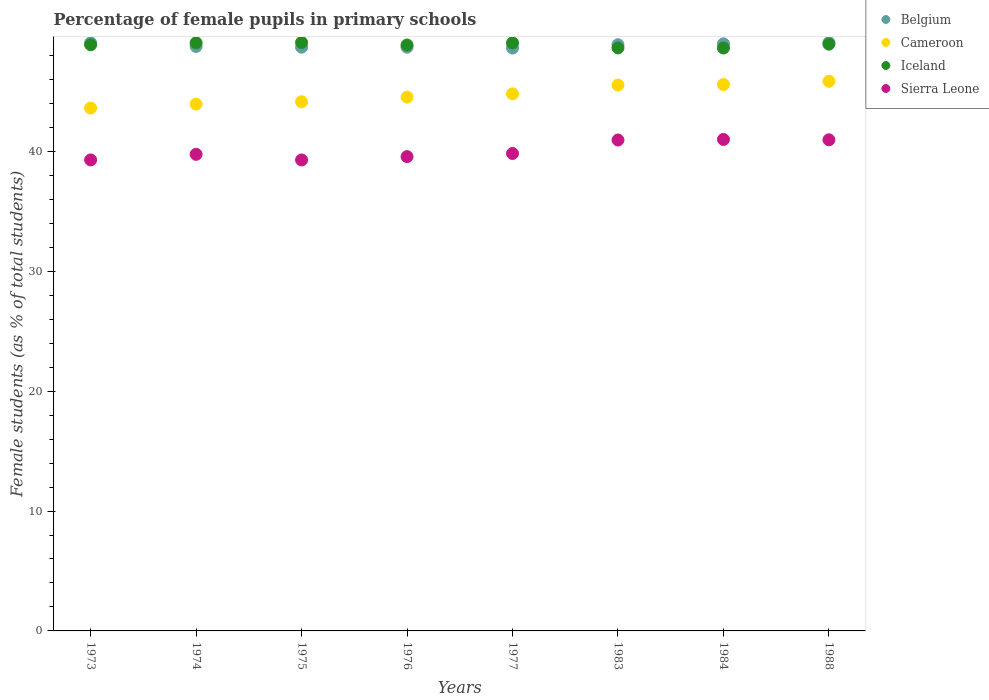Is the number of dotlines equal to the number of legend labels?
Keep it short and to the point. Yes. What is the percentage of female pupils in primary schools in Iceland in 1976?
Offer a terse response. 48.88. Across all years, what is the maximum percentage of female pupils in primary schools in Iceland?
Give a very brief answer. 49.09. Across all years, what is the minimum percentage of female pupils in primary schools in Sierra Leone?
Your response must be concise. 39.29. In which year was the percentage of female pupils in primary schools in Cameroon maximum?
Make the answer very short. 1988. What is the total percentage of female pupils in primary schools in Sierra Leone in the graph?
Offer a very short reply. 320.65. What is the difference between the percentage of female pupils in primary schools in Belgium in 1977 and that in 1988?
Provide a succinct answer. -0.45. What is the difference between the percentage of female pupils in primary schools in Cameroon in 1984 and the percentage of female pupils in primary schools in Iceland in 1976?
Your answer should be very brief. -3.3. What is the average percentage of female pupils in primary schools in Sierra Leone per year?
Your answer should be very brief. 40.08. In the year 1975, what is the difference between the percentage of female pupils in primary schools in Cameroon and percentage of female pupils in primary schools in Belgium?
Offer a terse response. -4.55. What is the ratio of the percentage of female pupils in primary schools in Belgium in 1973 to that in 1977?
Offer a terse response. 1.01. What is the difference between the highest and the second highest percentage of female pupils in primary schools in Sierra Leone?
Give a very brief answer. 0.03. What is the difference between the highest and the lowest percentage of female pupils in primary schools in Cameroon?
Ensure brevity in your answer.  2.23. In how many years, is the percentage of female pupils in primary schools in Cameroon greater than the average percentage of female pupils in primary schools in Cameroon taken over all years?
Your response must be concise. 4. Is the sum of the percentage of female pupils in primary schools in Sierra Leone in 1975 and 1984 greater than the maximum percentage of female pupils in primary schools in Cameroon across all years?
Make the answer very short. Yes. Does the percentage of female pupils in primary schools in Iceland monotonically increase over the years?
Your response must be concise. No. Is the percentage of female pupils in primary schools in Sierra Leone strictly greater than the percentage of female pupils in primary schools in Iceland over the years?
Ensure brevity in your answer.  No. How many dotlines are there?
Your answer should be compact. 4. How many years are there in the graph?
Keep it short and to the point. 8. Does the graph contain grids?
Offer a very short reply. No. How are the legend labels stacked?
Provide a succinct answer. Vertical. What is the title of the graph?
Provide a short and direct response. Percentage of female pupils in primary schools. What is the label or title of the Y-axis?
Your answer should be very brief. Female students (as % of total students). What is the Female students (as % of total students) in Belgium in 1973?
Keep it short and to the point. 49.05. What is the Female students (as % of total students) in Cameroon in 1973?
Ensure brevity in your answer.  43.62. What is the Female students (as % of total students) of Iceland in 1973?
Give a very brief answer. 48.9. What is the Female students (as % of total students) in Sierra Leone in 1973?
Make the answer very short. 39.29. What is the Female students (as % of total students) of Belgium in 1974?
Your answer should be very brief. 48.76. What is the Female students (as % of total students) of Cameroon in 1974?
Your response must be concise. 43.95. What is the Female students (as % of total students) in Iceland in 1974?
Keep it short and to the point. 49.06. What is the Female students (as % of total students) of Sierra Leone in 1974?
Ensure brevity in your answer.  39.76. What is the Female students (as % of total students) of Belgium in 1975?
Make the answer very short. 48.69. What is the Female students (as % of total students) of Cameroon in 1975?
Give a very brief answer. 44.14. What is the Female students (as % of total students) of Iceland in 1975?
Your answer should be compact. 49.09. What is the Female students (as % of total students) in Sierra Leone in 1975?
Give a very brief answer. 39.29. What is the Female students (as % of total students) of Belgium in 1976?
Provide a succinct answer. 48.69. What is the Female students (as % of total students) of Cameroon in 1976?
Keep it short and to the point. 44.53. What is the Female students (as % of total students) in Iceland in 1976?
Provide a short and direct response. 48.88. What is the Female students (as % of total students) of Sierra Leone in 1976?
Provide a succinct answer. 39.57. What is the Female students (as % of total students) of Belgium in 1977?
Provide a short and direct response. 48.62. What is the Female students (as % of total students) in Cameroon in 1977?
Provide a succinct answer. 44.81. What is the Female students (as % of total students) of Iceland in 1977?
Provide a succinct answer. 49.05. What is the Female students (as % of total students) in Sierra Leone in 1977?
Your answer should be compact. 39.83. What is the Female students (as % of total students) of Belgium in 1983?
Ensure brevity in your answer.  48.9. What is the Female students (as % of total students) of Cameroon in 1983?
Give a very brief answer. 45.54. What is the Female students (as % of total students) in Iceland in 1983?
Offer a terse response. 48.63. What is the Female students (as % of total students) of Sierra Leone in 1983?
Offer a very short reply. 40.95. What is the Female students (as % of total students) of Belgium in 1984?
Offer a terse response. 48.97. What is the Female students (as % of total students) of Cameroon in 1984?
Your response must be concise. 45.58. What is the Female students (as % of total students) of Iceland in 1984?
Provide a short and direct response. 48.63. What is the Female students (as % of total students) in Sierra Leone in 1984?
Your answer should be compact. 41. What is the Female students (as % of total students) of Belgium in 1988?
Provide a succinct answer. 49.07. What is the Female students (as % of total students) of Cameroon in 1988?
Make the answer very short. 45.85. What is the Female students (as % of total students) in Iceland in 1988?
Provide a short and direct response. 48.95. What is the Female students (as % of total students) of Sierra Leone in 1988?
Give a very brief answer. 40.97. Across all years, what is the maximum Female students (as % of total students) in Belgium?
Your answer should be very brief. 49.07. Across all years, what is the maximum Female students (as % of total students) of Cameroon?
Your response must be concise. 45.85. Across all years, what is the maximum Female students (as % of total students) in Iceland?
Your response must be concise. 49.09. Across all years, what is the maximum Female students (as % of total students) in Sierra Leone?
Ensure brevity in your answer.  41. Across all years, what is the minimum Female students (as % of total students) in Belgium?
Provide a succinct answer. 48.62. Across all years, what is the minimum Female students (as % of total students) of Cameroon?
Offer a terse response. 43.62. Across all years, what is the minimum Female students (as % of total students) of Iceland?
Give a very brief answer. 48.63. Across all years, what is the minimum Female students (as % of total students) of Sierra Leone?
Your response must be concise. 39.29. What is the total Female students (as % of total students) in Belgium in the graph?
Give a very brief answer. 390.77. What is the total Female students (as % of total students) of Cameroon in the graph?
Offer a very short reply. 358.01. What is the total Female students (as % of total students) in Iceland in the graph?
Offer a very short reply. 391.19. What is the total Female students (as % of total students) in Sierra Leone in the graph?
Ensure brevity in your answer.  320.65. What is the difference between the Female students (as % of total students) of Belgium in 1973 and that in 1974?
Your answer should be very brief. 0.29. What is the difference between the Female students (as % of total students) of Cameroon in 1973 and that in 1974?
Make the answer very short. -0.33. What is the difference between the Female students (as % of total students) in Iceland in 1973 and that in 1974?
Your answer should be compact. -0.16. What is the difference between the Female students (as % of total students) of Sierra Leone in 1973 and that in 1974?
Give a very brief answer. -0.46. What is the difference between the Female students (as % of total students) in Belgium in 1973 and that in 1975?
Provide a short and direct response. 0.36. What is the difference between the Female students (as % of total students) of Cameroon in 1973 and that in 1975?
Give a very brief answer. -0.52. What is the difference between the Female students (as % of total students) in Iceland in 1973 and that in 1975?
Your answer should be compact. -0.19. What is the difference between the Female students (as % of total students) of Sierra Leone in 1973 and that in 1975?
Offer a terse response. 0. What is the difference between the Female students (as % of total students) of Belgium in 1973 and that in 1976?
Your answer should be compact. 0.36. What is the difference between the Female students (as % of total students) of Cameroon in 1973 and that in 1976?
Your response must be concise. -0.91. What is the difference between the Female students (as % of total students) in Iceland in 1973 and that in 1976?
Offer a terse response. 0.02. What is the difference between the Female students (as % of total students) in Sierra Leone in 1973 and that in 1976?
Ensure brevity in your answer.  -0.27. What is the difference between the Female students (as % of total students) in Belgium in 1973 and that in 1977?
Your answer should be compact. 0.43. What is the difference between the Female students (as % of total students) in Cameroon in 1973 and that in 1977?
Offer a very short reply. -1.19. What is the difference between the Female students (as % of total students) in Iceland in 1973 and that in 1977?
Make the answer very short. -0.15. What is the difference between the Female students (as % of total students) in Sierra Leone in 1973 and that in 1977?
Ensure brevity in your answer.  -0.54. What is the difference between the Female students (as % of total students) in Belgium in 1973 and that in 1983?
Keep it short and to the point. 0.16. What is the difference between the Female students (as % of total students) in Cameroon in 1973 and that in 1983?
Your response must be concise. -1.92. What is the difference between the Female students (as % of total students) in Iceland in 1973 and that in 1983?
Offer a terse response. 0.27. What is the difference between the Female students (as % of total students) in Sierra Leone in 1973 and that in 1983?
Ensure brevity in your answer.  -1.66. What is the difference between the Female students (as % of total students) in Belgium in 1973 and that in 1984?
Provide a short and direct response. 0.08. What is the difference between the Female students (as % of total students) of Cameroon in 1973 and that in 1984?
Ensure brevity in your answer.  -1.96. What is the difference between the Female students (as % of total students) in Iceland in 1973 and that in 1984?
Keep it short and to the point. 0.27. What is the difference between the Female students (as % of total students) in Sierra Leone in 1973 and that in 1984?
Offer a terse response. -1.71. What is the difference between the Female students (as % of total students) in Belgium in 1973 and that in 1988?
Give a very brief answer. -0.02. What is the difference between the Female students (as % of total students) of Cameroon in 1973 and that in 1988?
Provide a succinct answer. -2.23. What is the difference between the Female students (as % of total students) in Iceland in 1973 and that in 1988?
Your response must be concise. -0.05. What is the difference between the Female students (as % of total students) in Sierra Leone in 1973 and that in 1988?
Give a very brief answer. -1.68. What is the difference between the Female students (as % of total students) in Belgium in 1974 and that in 1975?
Your answer should be compact. 0.07. What is the difference between the Female students (as % of total students) in Cameroon in 1974 and that in 1975?
Offer a very short reply. -0.19. What is the difference between the Female students (as % of total students) in Iceland in 1974 and that in 1975?
Give a very brief answer. -0.03. What is the difference between the Female students (as % of total students) of Sierra Leone in 1974 and that in 1975?
Give a very brief answer. 0.47. What is the difference between the Female students (as % of total students) in Belgium in 1974 and that in 1976?
Offer a very short reply. 0.06. What is the difference between the Female students (as % of total students) in Cameroon in 1974 and that in 1976?
Make the answer very short. -0.59. What is the difference between the Female students (as % of total students) in Iceland in 1974 and that in 1976?
Keep it short and to the point. 0.19. What is the difference between the Female students (as % of total students) in Sierra Leone in 1974 and that in 1976?
Your response must be concise. 0.19. What is the difference between the Female students (as % of total students) of Belgium in 1974 and that in 1977?
Provide a succinct answer. 0.13. What is the difference between the Female students (as % of total students) of Cameroon in 1974 and that in 1977?
Keep it short and to the point. -0.86. What is the difference between the Female students (as % of total students) in Iceland in 1974 and that in 1977?
Ensure brevity in your answer.  0.01. What is the difference between the Female students (as % of total students) in Sierra Leone in 1974 and that in 1977?
Make the answer very short. -0.07. What is the difference between the Female students (as % of total students) in Belgium in 1974 and that in 1983?
Your response must be concise. -0.14. What is the difference between the Female students (as % of total students) of Cameroon in 1974 and that in 1983?
Offer a terse response. -1.59. What is the difference between the Female students (as % of total students) in Iceland in 1974 and that in 1983?
Offer a very short reply. 0.43. What is the difference between the Female students (as % of total students) of Sierra Leone in 1974 and that in 1983?
Your response must be concise. -1.2. What is the difference between the Female students (as % of total students) in Belgium in 1974 and that in 1984?
Give a very brief answer. -0.22. What is the difference between the Female students (as % of total students) in Cameroon in 1974 and that in 1984?
Make the answer very short. -1.63. What is the difference between the Female students (as % of total students) in Iceland in 1974 and that in 1984?
Make the answer very short. 0.43. What is the difference between the Female students (as % of total students) of Sierra Leone in 1974 and that in 1984?
Keep it short and to the point. -1.24. What is the difference between the Female students (as % of total students) in Belgium in 1974 and that in 1988?
Your answer should be compact. -0.32. What is the difference between the Female students (as % of total students) of Cameroon in 1974 and that in 1988?
Your answer should be compact. -1.9. What is the difference between the Female students (as % of total students) of Iceland in 1974 and that in 1988?
Make the answer very short. 0.11. What is the difference between the Female students (as % of total students) in Sierra Leone in 1974 and that in 1988?
Give a very brief answer. -1.22. What is the difference between the Female students (as % of total students) of Belgium in 1975 and that in 1976?
Keep it short and to the point. -0. What is the difference between the Female students (as % of total students) of Cameroon in 1975 and that in 1976?
Keep it short and to the point. -0.39. What is the difference between the Female students (as % of total students) in Iceland in 1975 and that in 1976?
Offer a very short reply. 0.21. What is the difference between the Female students (as % of total students) in Sierra Leone in 1975 and that in 1976?
Offer a very short reply. -0.28. What is the difference between the Female students (as % of total students) of Belgium in 1975 and that in 1977?
Provide a short and direct response. 0.07. What is the difference between the Female students (as % of total students) of Cameroon in 1975 and that in 1977?
Your response must be concise. -0.66. What is the difference between the Female students (as % of total students) of Iceland in 1975 and that in 1977?
Keep it short and to the point. 0.04. What is the difference between the Female students (as % of total students) of Sierra Leone in 1975 and that in 1977?
Provide a short and direct response. -0.54. What is the difference between the Female students (as % of total students) of Belgium in 1975 and that in 1983?
Offer a very short reply. -0.2. What is the difference between the Female students (as % of total students) in Cameroon in 1975 and that in 1983?
Provide a succinct answer. -1.39. What is the difference between the Female students (as % of total students) of Iceland in 1975 and that in 1983?
Your answer should be compact. 0.46. What is the difference between the Female students (as % of total students) of Sierra Leone in 1975 and that in 1983?
Provide a succinct answer. -1.66. What is the difference between the Female students (as % of total students) of Belgium in 1975 and that in 1984?
Offer a terse response. -0.28. What is the difference between the Female students (as % of total students) of Cameroon in 1975 and that in 1984?
Provide a succinct answer. -1.44. What is the difference between the Female students (as % of total students) of Iceland in 1975 and that in 1984?
Provide a short and direct response. 0.46. What is the difference between the Female students (as % of total students) in Sierra Leone in 1975 and that in 1984?
Your answer should be very brief. -1.71. What is the difference between the Female students (as % of total students) of Belgium in 1975 and that in 1988?
Keep it short and to the point. -0.38. What is the difference between the Female students (as % of total students) of Cameroon in 1975 and that in 1988?
Your answer should be very brief. -1.71. What is the difference between the Female students (as % of total students) in Iceland in 1975 and that in 1988?
Give a very brief answer. 0.14. What is the difference between the Female students (as % of total students) of Sierra Leone in 1975 and that in 1988?
Keep it short and to the point. -1.68. What is the difference between the Female students (as % of total students) in Belgium in 1976 and that in 1977?
Your answer should be very brief. 0.07. What is the difference between the Female students (as % of total students) of Cameroon in 1976 and that in 1977?
Your answer should be compact. -0.27. What is the difference between the Female students (as % of total students) in Iceland in 1976 and that in 1977?
Offer a terse response. -0.18. What is the difference between the Female students (as % of total students) of Sierra Leone in 1976 and that in 1977?
Keep it short and to the point. -0.26. What is the difference between the Female students (as % of total students) in Belgium in 1976 and that in 1983?
Ensure brevity in your answer.  -0.2. What is the difference between the Female students (as % of total students) in Cameroon in 1976 and that in 1983?
Provide a short and direct response. -1. What is the difference between the Female students (as % of total students) of Iceland in 1976 and that in 1983?
Give a very brief answer. 0.24. What is the difference between the Female students (as % of total students) of Sierra Leone in 1976 and that in 1983?
Give a very brief answer. -1.39. What is the difference between the Female students (as % of total students) of Belgium in 1976 and that in 1984?
Offer a very short reply. -0.28. What is the difference between the Female students (as % of total students) of Cameroon in 1976 and that in 1984?
Make the answer very short. -1.05. What is the difference between the Female students (as % of total students) of Iceland in 1976 and that in 1984?
Provide a succinct answer. 0.25. What is the difference between the Female students (as % of total students) in Sierra Leone in 1976 and that in 1984?
Offer a terse response. -1.43. What is the difference between the Female students (as % of total students) of Belgium in 1976 and that in 1988?
Provide a short and direct response. -0.38. What is the difference between the Female students (as % of total students) of Cameroon in 1976 and that in 1988?
Offer a terse response. -1.32. What is the difference between the Female students (as % of total students) in Iceland in 1976 and that in 1988?
Give a very brief answer. -0.07. What is the difference between the Female students (as % of total students) of Sierra Leone in 1976 and that in 1988?
Offer a very short reply. -1.41. What is the difference between the Female students (as % of total students) in Belgium in 1977 and that in 1983?
Your answer should be very brief. -0.27. What is the difference between the Female students (as % of total students) in Cameroon in 1977 and that in 1983?
Give a very brief answer. -0.73. What is the difference between the Female students (as % of total students) of Iceland in 1977 and that in 1983?
Keep it short and to the point. 0.42. What is the difference between the Female students (as % of total students) in Sierra Leone in 1977 and that in 1983?
Your answer should be very brief. -1.12. What is the difference between the Female students (as % of total students) of Belgium in 1977 and that in 1984?
Make the answer very short. -0.35. What is the difference between the Female students (as % of total students) of Cameroon in 1977 and that in 1984?
Give a very brief answer. -0.77. What is the difference between the Female students (as % of total students) in Iceland in 1977 and that in 1984?
Give a very brief answer. 0.42. What is the difference between the Female students (as % of total students) in Sierra Leone in 1977 and that in 1984?
Keep it short and to the point. -1.17. What is the difference between the Female students (as % of total students) in Belgium in 1977 and that in 1988?
Offer a terse response. -0.45. What is the difference between the Female students (as % of total students) of Cameroon in 1977 and that in 1988?
Give a very brief answer. -1.05. What is the difference between the Female students (as % of total students) of Iceland in 1977 and that in 1988?
Ensure brevity in your answer.  0.1. What is the difference between the Female students (as % of total students) in Sierra Leone in 1977 and that in 1988?
Offer a very short reply. -1.14. What is the difference between the Female students (as % of total students) in Belgium in 1983 and that in 1984?
Your response must be concise. -0.08. What is the difference between the Female students (as % of total students) of Cameroon in 1983 and that in 1984?
Keep it short and to the point. -0.04. What is the difference between the Female students (as % of total students) in Iceland in 1983 and that in 1984?
Give a very brief answer. 0.01. What is the difference between the Female students (as % of total students) of Sierra Leone in 1983 and that in 1984?
Offer a terse response. -0.05. What is the difference between the Female students (as % of total students) of Belgium in 1983 and that in 1988?
Offer a very short reply. -0.18. What is the difference between the Female students (as % of total students) in Cameroon in 1983 and that in 1988?
Your answer should be very brief. -0.32. What is the difference between the Female students (as % of total students) of Iceland in 1983 and that in 1988?
Provide a short and direct response. -0.32. What is the difference between the Female students (as % of total students) in Sierra Leone in 1983 and that in 1988?
Ensure brevity in your answer.  -0.02. What is the difference between the Female students (as % of total students) in Belgium in 1984 and that in 1988?
Give a very brief answer. -0.1. What is the difference between the Female students (as % of total students) in Cameroon in 1984 and that in 1988?
Offer a terse response. -0.27. What is the difference between the Female students (as % of total students) of Iceland in 1984 and that in 1988?
Give a very brief answer. -0.32. What is the difference between the Female students (as % of total students) of Sierra Leone in 1984 and that in 1988?
Your answer should be compact. 0.03. What is the difference between the Female students (as % of total students) in Belgium in 1973 and the Female students (as % of total students) in Cameroon in 1974?
Give a very brief answer. 5.11. What is the difference between the Female students (as % of total students) of Belgium in 1973 and the Female students (as % of total students) of Iceland in 1974?
Offer a very short reply. -0.01. What is the difference between the Female students (as % of total students) in Belgium in 1973 and the Female students (as % of total students) in Sierra Leone in 1974?
Make the answer very short. 9.3. What is the difference between the Female students (as % of total students) of Cameroon in 1973 and the Female students (as % of total students) of Iceland in 1974?
Provide a succinct answer. -5.44. What is the difference between the Female students (as % of total students) in Cameroon in 1973 and the Female students (as % of total students) in Sierra Leone in 1974?
Provide a succinct answer. 3.86. What is the difference between the Female students (as % of total students) of Iceland in 1973 and the Female students (as % of total students) of Sierra Leone in 1974?
Your response must be concise. 9.14. What is the difference between the Female students (as % of total students) in Belgium in 1973 and the Female students (as % of total students) in Cameroon in 1975?
Offer a very short reply. 4.91. What is the difference between the Female students (as % of total students) of Belgium in 1973 and the Female students (as % of total students) of Iceland in 1975?
Your answer should be very brief. -0.04. What is the difference between the Female students (as % of total students) in Belgium in 1973 and the Female students (as % of total students) in Sierra Leone in 1975?
Make the answer very short. 9.76. What is the difference between the Female students (as % of total students) of Cameroon in 1973 and the Female students (as % of total students) of Iceland in 1975?
Give a very brief answer. -5.47. What is the difference between the Female students (as % of total students) of Cameroon in 1973 and the Female students (as % of total students) of Sierra Leone in 1975?
Keep it short and to the point. 4.33. What is the difference between the Female students (as % of total students) of Iceland in 1973 and the Female students (as % of total students) of Sierra Leone in 1975?
Make the answer very short. 9.61. What is the difference between the Female students (as % of total students) in Belgium in 1973 and the Female students (as % of total students) in Cameroon in 1976?
Your answer should be compact. 4.52. What is the difference between the Female students (as % of total students) in Belgium in 1973 and the Female students (as % of total students) in Iceland in 1976?
Ensure brevity in your answer.  0.18. What is the difference between the Female students (as % of total students) in Belgium in 1973 and the Female students (as % of total students) in Sierra Leone in 1976?
Give a very brief answer. 9.49. What is the difference between the Female students (as % of total students) in Cameroon in 1973 and the Female students (as % of total students) in Iceland in 1976?
Provide a succinct answer. -5.26. What is the difference between the Female students (as % of total students) of Cameroon in 1973 and the Female students (as % of total students) of Sierra Leone in 1976?
Your answer should be very brief. 4.05. What is the difference between the Female students (as % of total students) of Iceland in 1973 and the Female students (as % of total students) of Sierra Leone in 1976?
Give a very brief answer. 9.33. What is the difference between the Female students (as % of total students) in Belgium in 1973 and the Female students (as % of total students) in Cameroon in 1977?
Give a very brief answer. 4.25. What is the difference between the Female students (as % of total students) of Belgium in 1973 and the Female students (as % of total students) of Iceland in 1977?
Provide a short and direct response. 0. What is the difference between the Female students (as % of total students) of Belgium in 1973 and the Female students (as % of total students) of Sierra Leone in 1977?
Your answer should be compact. 9.23. What is the difference between the Female students (as % of total students) of Cameroon in 1973 and the Female students (as % of total students) of Iceland in 1977?
Make the answer very short. -5.43. What is the difference between the Female students (as % of total students) in Cameroon in 1973 and the Female students (as % of total students) in Sierra Leone in 1977?
Your response must be concise. 3.79. What is the difference between the Female students (as % of total students) of Iceland in 1973 and the Female students (as % of total students) of Sierra Leone in 1977?
Provide a succinct answer. 9.07. What is the difference between the Female students (as % of total students) of Belgium in 1973 and the Female students (as % of total students) of Cameroon in 1983?
Your answer should be compact. 3.52. What is the difference between the Female students (as % of total students) of Belgium in 1973 and the Female students (as % of total students) of Iceland in 1983?
Keep it short and to the point. 0.42. What is the difference between the Female students (as % of total students) in Belgium in 1973 and the Female students (as % of total students) in Sierra Leone in 1983?
Give a very brief answer. 8.1. What is the difference between the Female students (as % of total students) in Cameroon in 1973 and the Female students (as % of total students) in Iceland in 1983?
Provide a succinct answer. -5.02. What is the difference between the Female students (as % of total students) in Cameroon in 1973 and the Female students (as % of total students) in Sierra Leone in 1983?
Keep it short and to the point. 2.67. What is the difference between the Female students (as % of total students) in Iceland in 1973 and the Female students (as % of total students) in Sierra Leone in 1983?
Make the answer very short. 7.95. What is the difference between the Female students (as % of total students) in Belgium in 1973 and the Female students (as % of total students) in Cameroon in 1984?
Your answer should be compact. 3.47. What is the difference between the Female students (as % of total students) of Belgium in 1973 and the Female students (as % of total students) of Iceland in 1984?
Make the answer very short. 0.43. What is the difference between the Female students (as % of total students) of Belgium in 1973 and the Female students (as % of total students) of Sierra Leone in 1984?
Your answer should be very brief. 8.05. What is the difference between the Female students (as % of total students) of Cameroon in 1973 and the Female students (as % of total students) of Iceland in 1984?
Offer a very short reply. -5.01. What is the difference between the Female students (as % of total students) of Cameroon in 1973 and the Female students (as % of total students) of Sierra Leone in 1984?
Your answer should be compact. 2.62. What is the difference between the Female students (as % of total students) in Iceland in 1973 and the Female students (as % of total students) in Sierra Leone in 1984?
Offer a very short reply. 7.9. What is the difference between the Female students (as % of total students) of Belgium in 1973 and the Female students (as % of total students) of Cameroon in 1988?
Your answer should be compact. 3.2. What is the difference between the Female students (as % of total students) in Belgium in 1973 and the Female students (as % of total students) in Iceland in 1988?
Your response must be concise. 0.1. What is the difference between the Female students (as % of total students) in Belgium in 1973 and the Female students (as % of total students) in Sierra Leone in 1988?
Offer a very short reply. 8.08. What is the difference between the Female students (as % of total students) in Cameroon in 1973 and the Female students (as % of total students) in Iceland in 1988?
Provide a succinct answer. -5.33. What is the difference between the Female students (as % of total students) in Cameroon in 1973 and the Female students (as % of total students) in Sierra Leone in 1988?
Give a very brief answer. 2.65. What is the difference between the Female students (as % of total students) in Iceland in 1973 and the Female students (as % of total students) in Sierra Leone in 1988?
Make the answer very short. 7.93. What is the difference between the Female students (as % of total students) of Belgium in 1974 and the Female students (as % of total students) of Cameroon in 1975?
Ensure brevity in your answer.  4.62. What is the difference between the Female students (as % of total students) of Belgium in 1974 and the Female students (as % of total students) of Iceland in 1975?
Your answer should be compact. -0.33. What is the difference between the Female students (as % of total students) of Belgium in 1974 and the Female students (as % of total students) of Sierra Leone in 1975?
Your answer should be compact. 9.47. What is the difference between the Female students (as % of total students) of Cameroon in 1974 and the Female students (as % of total students) of Iceland in 1975?
Keep it short and to the point. -5.14. What is the difference between the Female students (as % of total students) in Cameroon in 1974 and the Female students (as % of total students) in Sierra Leone in 1975?
Make the answer very short. 4.66. What is the difference between the Female students (as % of total students) in Iceland in 1974 and the Female students (as % of total students) in Sierra Leone in 1975?
Keep it short and to the point. 9.77. What is the difference between the Female students (as % of total students) of Belgium in 1974 and the Female students (as % of total students) of Cameroon in 1976?
Offer a terse response. 4.23. What is the difference between the Female students (as % of total students) of Belgium in 1974 and the Female students (as % of total students) of Iceland in 1976?
Make the answer very short. -0.12. What is the difference between the Female students (as % of total students) of Belgium in 1974 and the Female students (as % of total students) of Sierra Leone in 1976?
Your answer should be very brief. 9.19. What is the difference between the Female students (as % of total students) of Cameroon in 1974 and the Female students (as % of total students) of Iceland in 1976?
Ensure brevity in your answer.  -4.93. What is the difference between the Female students (as % of total students) in Cameroon in 1974 and the Female students (as % of total students) in Sierra Leone in 1976?
Your response must be concise. 4.38. What is the difference between the Female students (as % of total students) of Iceland in 1974 and the Female students (as % of total students) of Sierra Leone in 1976?
Provide a short and direct response. 9.49. What is the difference between the Female students (as % of total students) of Belgium in 1974 and the Female students (as % of total students) of Cameroon in 1977?
Ensure brevity in your answer.  3.95. What is the difference between the Female students (as % of total students) of Belgium in 1974 and the Female students (as % of total students) of Iceland in 1977?
Provide a short and direct response. -0.29. What is the difference between the Female students (as % of total students) in Belgium in 1974 and the Female students (as % of total students) in Sierra Leone in 1977?
Your answer should be compact. 8.93. What is the difference between the Female students (as % of total students) of Cameroon in 1974 and the Female students (as % of total students) of Iceland in 1977?
Provide a succinct answer. -5.1. What is the difference between the Female students (as % of total students) in Cameroon in 1974 and the Female students (as % of total students) in Sierra Leone in 1977?
Your answer should be compact. 4.12. What is the difference between the Female students (as % of total students) in Iceland in 1974 and the Female students (as % of total students) in Sierra Leone in 1977?
Keep it short and to the point. 9.23. What is the difference between the Female students (as % of total students) in Belgium in 1974 and the Female students (as % of total students) in Cameroon in 1983?
Offer a terse response. 3.22. What is the difference between the Female students (as % of total students) of Belgium in 1974 and the Female students (as % of total students) of Iceland in 1983?
Provide a short and direct response. 0.13. What is the difference between the Female students (as % of total students) of Belgium in 1974 and the Female students (as % of total students) of Sierra Leone in 1983?
Give a very brief answer. 7.81. What is the difference between the Female students (as % of total students) in Cameroon in 1974 and the Female students (as % of total students) in Iceland in 1983?
Your answer should be very brief. -4.69. What is the difference between the Female students (as % of total students) in Cameroon in 1974 and the Female students (as % of total students) in Sierra Leone in 1983?
Your answer should be compact. 3. What is the difference between the Female students (as % of total students) in Iceland in 1974 and the Female students (as % of total students) in Sierra Leone in 1983?
Give a very brief answer. 8.11. What is the difference between the Female students (as % of total students) in Belgium in 1974 and the Female students (as % of total students) in Cameroon in 1984?
Provide a succinct answer. 3.18. What is the difference between the Female students (as % of total students) in Belgium in 1974 and the Female students (as % of total students) in Iceland in 1984?
Provide a succinct answer. 0.13. What is the difference between the Female students (as % of total students) in Belgium in 1974 and the Female students (as % of total students) in Sierra Leone in 1984?
Ensure brevity in your answer.  7.76. What is the difference between the Female students (as % of total students) of Cameroon in 1974 and the Female students (as % of total students) of Iceland in 1984?
Provide a short and direct response. -4.68. What is the difference between the Female students (as % of total students) in Cameroon in 1974 and the Female students (as % of total students) in Sierra Leone in 1984?
Provide a short and direct response. 2.95. What is the difference between the Female students (as % of total students) of Iceland in 1974 and the Female students (as % of total students) of Sierra Leone in 1984?
Make the answer very short. 8.06. What is the difference between the Female students (as % of total students) of Belgium in 1974 and the Female students (as % of total students) of Cameroon in 1988?
Offer a terse response. 2.91. What is the difference between the Female students (as % of total students) of Belgium in 1974 and the Female students (as % of total students) of Iceland in 1988?
Offer a terse response. -0.19. What is the difference between the Female students (as % of total students) in Belgium in 1974 and the Female students (as % of total students) in Sierra Leone in 1988?
Your answer should be compact. 7.79. What is the difference between the Female students (as % of total students) of Cameroon in 1974 and the Female students (as % of total students) of Iceland in 1988?
Offer a terse response. -5. What is the difference between the Female students (as % of total students) in Cameroon in 1974 and the Female students (as % of total students) in Sierra Leone in 1988?
Your answer should be very brief. 2.98. What is the difference between the Female students (as % of total students) in Iceland in 1974 and the Female students (as % of total students) in Sierra Leone in 1988?
Ensure brevity in your answer.  8.09. What is the difference between the Female students (as % of total students) in Belgium in 1975 and the Female students (as % of total students) in Cameroon in 1976?
Offer a very short reply. 4.16. What is the difference between the Female students (as % of total students) of Belgium in 1975 and the Female students (as % of total students) of Iceland in 1976?
Offer a very short reply. -0.18. What is the difference between the Female students (as % of total students) in Belgium in 1975 and the Female students (as % of total students) in Sierra Leone in 1976?
Provide a short and direct response. 9.13. What is the difference between the Female students (as % of total students) in Cameroon in 1975 and the Female students (as % of total students) in Iceland in 1976?
Make the answer very short. -4.73. What is the difference between the Female students (as % of total students) of Cameroon in 1975 and the Female students (as % of total students) of Sierra Leone in 1976?
Your answer should be compact. 4.58. What is the difference between the Female students (as % of total students) of Iceland in 1975 and the Female students (as % of total students) of Sierra Leone in 1976?
Make the answer very short. 9.52. What is the difference between the Female students (as % of total students) in Belgium in 1975 and the Female students (as % of total students) in Cameroon in 1977?
Keep it short and to the point. 3.89. What is the difference between the Female students (as % of total students) in Belgium in 1975 and the Female students (as % of total students) in Iceland in 1977?
Give a very brief answer. -0.36. What is the difference between the Female students (as % of total students) of Belgium in 1975 and the Female students (as % of total students) of Sierra Leone in 1977?
Provide a succinct answer. 8.87. What is the difference between the Female students (as % of total students) in Cameroon in 1975 and the Female students (as % of total students) in Iceland in 1977?
Your answer should be very brief. -4.91. What is the difference between the Female students (as % of total students) of Cameroon in 1975 and the Female students (as % of total students) of Sierra Leone in 1977?
Give a very brief answer. 4.31. What is the difference between the Female students (as % of total students) in Iceland in 1975 and the Female students (as % of total students) in Sierra Leone in 1977?
Provide a succinct answer. 9.26. What is the difference between the Female students (as % of total students) of Belgium in 1975 and the Female students (as % of total students) of Cameroon in 1983?
Keep it short and to the point. 3.16. What is the difference between the Female students (as % of total students) in Belgium in 1975 and the Female students (as % of total students) in Iceland in 1983?
Provide a short and direct response. 0.06. What is the difference between the Female students (as % of total students) of Belgium in 1975 and the Female students (as % of total students) of Sierra Leone in 1983?
Your response must be concise. 7.74. What is the difference between the Female students (as % of total students) of Cameroon in 1975 and the Female students (as % of total students) of Iceland in 1983?
Your answer should be very brief. -4.49. What is the difference between the Female students (as % of total students) in Cameroon in 1975 and the Female students (as % of total students) in Sierra Leone in 1983?
Provide a short and direct response. 3.19. What is the difference between the Female students (as % of total students) of Iceland in 1975 and the Female students (as % of total students) of Sierra Leone in 1983?
Offer a very short reply. 8.14. What is the difference between the Female students (as % of total students) of Belgium in 1975 and the Female students (as % of total students) of Cameroon in 1984?
Provide a succinct answer. 3.11. What is the difference between the Female students (as % of total students) of Belgium in 1975 and the Female students (as % of total students) of Iceland in 1984?
Your answer should be compact. 0.07. What is the difference between the Female students (as % of total students) of Belgium in 1975 and the Female students (as % of total students) of Sierra Leone in 1984?
Keep it short and to the point. 7.69. What is the difference between the Female students (as % of total students) of Cameroon in 1975 and the Female students (as % of total students) of Iceland in 1984?
Your answer should be very brief. -4.49. What is the difference between the Female students (as % of total students) in Cameroon in 1975 and the Female students (as % of total students) in Sierra Leone in 1984?
Give a very brief answer. 3.14. What is the difference between the Female students (as % of total students) of Iceland in 1975 and the Female students (as % of total students) of Sierra Leone in 1984?
Ensure brevity in your answer.  8.09. What is the difference between the Female students (as % of total students) in Belgium in 1975 and the Female students (as % of total students) in Cameroon in 1988?
Make the answer very short. 2.84. What is the difference between the Female students (as % of total students) in Belgium in 1975 and the Female students (as % of total students) in Iceland in 1988?
Give a very brief answer. -0.26. What is the difference between the Female students (as % of total students) of Belgium in 1975 and the Female students (as % of total students) of Sierra Leone in 1988?
Your response must be concise. 7.72. What is the difference between the Female students (as % of total students) of Cameroon in 1975 and the Female students (as % of total students) of Iceland in 1988?
Your answer should be compact. -4.81. What is the difference between the Female students (as % of total students) in Cameroon in 1975 and the Female students (as % of total students) in Sierra Leone in 1988?
Provide a short and direct response. 3.17. What is the difference between the Female students (as % of total students) in Iceland in 1975 and the Female students (as % of total students) in Sierra Leone in 1988?
Provide a succinct answer. 8.12. What is the difference between the Female students (as % of total students) of Belgium in 1976 and the Female students (as % of total students) of Cameroon in 1977?
Provide a short and direct response. 3.89. What is the difference between the Female students (as % of total students) of Belgium in 1976 and the Female students (as % of total students) of Iceland in 1977?
Your response must be concise. -0.36. What is the difference between the Female students (as % of total students) of Belgium in 1976 and the Female students (as % of total students) of Sierra Leone in 1977?
Keep it short and to the point. 8.87. What is the difference between the Female students (as % of total students) of Cameroon in 1976 and the Female students (as % of total students) of Iceland in 1977?
Your answer should be very brief. -4.52. What is the difference between the Female students (as % of total students) in Cameroon in 1976 and the Female students (as % of total students) in Sierra Leone in 1977?
Your answer should be compact. 4.7. What is the difference between the Female students (as % of total students) in Iceland in 1976 and the Female students (as % of total students) in Sierra Leone in 1977?
Keep it short and to the point. 9.05. What is the difference between the Female students (as % of total students) of Belgium in 1976 and the Female students (as % of total students) of Cameroon in 1983?
Offer a very short reply. 3.16. What is the difference between the Female students (as % of total students) in Belgium in 1976 and the Female students (as % of total students) in Iceland in 1983?
Provide a succinct answer. 0.06. What is the difference between the Female students (as % of total students) in Belgium in 1976 and the Female students (as % of total students) in Sierra Leone in 1983?
Offer a very short reply. 7.74. What is the difference between the Female students (as % of total students) of Cameroon in 1976 and the Female students (as % of total students) of Iceland in 1983?
Your response must be concise. -4.1. What is the difference between the Female students (as % of total students) in Cameroon in 1976 and the Female students (as % of total students) in Sierra Leone in 1983?
Offer a very short reply. 3.58. What is the difference between the Female students (as % of total students) in Iceland in 1976 and the Female students (as % of total students) in Sierra Leone in 1983?
Make the answer very short. 7.92. What is the difference between the Female students (as % of total students) in Belgium in 1976 and the Female students (as % of total students) in Cameroon in 1984?
Provide a succinct answer. 3.12. What is the difference between the Female students (as % of total students) of Belgium in 1976 and the Female students (as % of total students) of Iceland in 1984?
Your answer should be compact. 0.07. What is the difference between the Female students (as % of total students) in Belgium in 1976 and the Female students (as % of total students) in Sierra Leone in 1984?
Your answer should be compact. 7.69. What is the difference between the Female students (as % of total students) of Cameroon in 1976 and the Female students (as % of total students) of Iceland in 1984?
Your response must be concise. -4.1. What is the difference between the Female students (as % of total students) in Cameroon in 1976 and the Female students (as % of total students) in Sierra Leone in 1984?
Keep it short and to the point. 3.53. What is the difference between the Female students (as % of total students) in Iceland in 1976 and the Female students (as % of total students) in Sierra Leone in 1984?
Your answer should be compact. 7.88. What is the difference between the Female students (as % of total students) in Belgium in 1976 and the Female students (as % of total students) in Cameroon in 1988?
Offer a terse response. 2.84. What is the difference between the Female students (as % of total students) of Belgium in 1976 and the Female students (as % of total students) of Iceland in 1988?
Make the answer very short. -0.25. What is the difference between the Female students (as % of total students) of Belgium in 1976 and the Female students (as % of total students) of Sierra Leone in 1988?
Provide a succinct answer. 7.72. What is the difference between the Female students (as % of total students) of Cameroon in 1976 and the Female students (as % of total students) of Iceland in 1988?
Provide a short and direct response. -4.42. What is the difference between the Female students (as % of total students) of Cameroon in 1976 and the Female students (as % of total students) of Sierra Leone in 1988?
Make the answer very short. 3.56. What is the difference between the Female students (as % of total students) in Iceland in 1976 and the Female students (as % of total students) in Sierra Leone in 1988?
Keep it short and to the point. 7.9. What is the difference between the Female students (as % of total students) in Belgium in 1977 and the Female students (as % of total students) in Cameroon in 1983?
Keep it short and to the point. 3.09. What is the difference between the Female students (as % of total students) in Belgium in 1977 and the Female students (as % of total students) in Iceland in 1983?
Your answer should be compact. -0.01. What is the difference between the Female students (as % of total students) in Belgium in 1977 and the Female students (as % of total students) in Sierra Leone in 1983?
Your answer should be very brief. 7.67. What is the difference between the Female students (as % of total students) of Cameroon in 1977 and the Female students (as % of total students) of Iceland in 1983?
Offer a very short reply. -3.83. What is the difference between the Female students (as % of total students) of Cameroon in 1977 and the Female students (as % of total students) of Sierra Leone in 1983?
Make the answer very short. 3.85. What is the difference between the Female students (as % of total students) in Iceland in 1977 and the Female students (as % of total students) in Sierra Leone in 1983?
Your response must be concise. 8.1. What is the difference between the Female students (as % of total students) of Belgium in 1977 and the Female students (as % of total students) of Cameroon in 1984?
Give a very brief answer. 3.05. What is the difference between the Female students (as % of total students) of Belgium in 1977 and the Female students (as % of total students) of Iceland in 1984?
Keep it short and to the point. -0. What is the difference between the Female students (as % of total students) of Belgium in 1977 and the Female students (as % of total students) of Sierra Leone in 1984?
Offer a very short reply. 7.62. What is the difference between the Female students (as % of total students) of Cameroon in 1977 and the Female students (as % of total students) of Iceland in 1984?
Keep it short and to the point. -3.82. What is the difference between the Female students (as % of total students) in Cameroon in 1977 and the Female students (as % of total students) in Sierra Leone in 1984?
Provide a short and direct response. 3.81. What is the difference between the Female students (as % of total students) of Iceland in 1977 and the Female students (as % of total students) of Sierra Leone in 1984?
Offer a very short reply. 8.05. What is the difference between the Female students (as % of total students) of Belgium in 1977 and the Female students (as % of total students) of Cameroon in 1988?
Provide a short and direct response. 2.77. What is the difference between the Female students (as % of total students) in Belgium in 1977 and the Female students (as % of total students) in Iceland in 1988?
Offer a very short reply. -0.32. What is the difference between the Female students (as % of total students) in Belgium in 1977 and the Female students (as % of total students) in Sierra Leone in 1988?
Your answer should be very brief. 7.65. What is the difference between the Female students (as % of total students) of Cameroon in 1977 and the Female students (as % of total students) of Iceland in 1988?
Your response must be concise. -4.14. What is the difference between the Female students (as % of total students) in Cameroon in 1977 and the Female students (as % of total students) in Sierra Leone in 1988?
Keep it short and to the point. 3.83. What is the difference between the Female students (as % of total students) in Iceland in 1977 and the Female students (as % of total students) in Sierra Leone in 1988?
Your answer should be compact. 8.08. What is the difference between the Female students (as % of total students) in Belgium in 1983 and the Female students (as % of total students) in Cameroon in 1984?
Make the answer very short. 3.32. What is the difference between the Female students (as % of total students) in Belgium in 1983 and the Female students (as % of total students) in Iceland in 1984?
Offer a terse response. 0.27. What is the difference between the Female students (as % of total students) in Belgium in 1983 and the Female students (as % of total students) in Sierra Leone in 1984?
Your answer should be very brief. 7.9. What is the difference between the Female students (as % of total students) in Cameroon in 1983 and the Female students (as % of total students) in Iceland in 1984?
Your response must be concise. -3.09. What is the difference between the Female students (as % of total students) in Cameroon in 1983 and the Female students (as % of total students) in Sierra Leone in 1984?
Provide a succinct answer. 4.54. What is the difference between the Female students (as % of total students) of Iceland in 1983 and the Female students (as % of total students) of Sierra Leone in 1984?
Ensure brevity in your answer.  7.63. What is the difference between the Female students (as % of total students) of Belgium in 1983 and the Female students (as % of total students) of Cameroon in 1988?
Your answer should be very brief. 3.05. What is the difference between the Female students (as % of total students) of Belgium in 1983 and the Female students (as % of total students) of Iceland in 1988?
Offer a very short reply. -0.05. What is the difference between the Female students (as % of total students) in Belgium in 1983 and the Female students (as % of total students) in Sierra Leone in 1988?
Make the answer very short. 7.93. What is the difference between the Female students (as % of total students) in Cameroon in 1983 and the Female students (as % of total students) in Iceland in 1988?
Provide a short and direct response. -3.41. What is the difference between the Female students (as % of total students) in Cameroon in 1983 and the Female students (as % of total students) in Sierra Leone in 1988?
Provide a succinct answer. 4.56. What is the difference between the Female students (as % of total students) of Iceland in 1983 and the Female students (as % of total students) of Sierra Leone in 1988?
Offer a terse response. 7.66. What is the difference between the Female students (as % of total students) in Belgium in 1984 and the Female students (as % of total students) in Cameroon in 1988?
Give a very brief answer. 3.12. What is the difference between the Female students (as % of total students) of Belgium in 1984 and the Female students (as % of total students) of Iceland in 1988?
Offer a very short reply. 0.03. What is the difference between the Female students (as % of total students) of Belgium in 1984 and the Female students (as % of total students) of Sierra Leone in 1988?
Offer a terse response. 8. What is the difference between the Female students (as % of total students) in Cameroon in 1984 and the Female students (as % of total students) in Iceland in 1988?
Offer a terse response. -3.37. What is the difference between the Female students (as % of total students) of Cameroon in 1984 and the Female students (as % of total students) of Sierra Leone in 1988?
Ensure brevity in your answer.  4.61. What is the difference between the Female students (as % of total students) in Iceland in 1984 and the Female students (as % of total students) in Sierra Leone in 1988?
Provide a short and direct response. 7.66. What is the average Female students (as % of total students) in Belgium per year?
Offer a terse response. 48.85. What is the average Female students (as % of total students) in Cameroon per year?
Offer a terse response. 44.75. What is the average Female students (as % of total students) in Iceland per year?
Provide a short and direct response. 48.9. What is the average Female students (as % of total students) in Sierra Leone per year?
Provide a succinct answer. 40.08. In the year 1973, what is the difference between the Female students (as % of total students) of Belgium and Female students (as % of total students) of Cameroon?
Your answer should be compact. 5.44. In the year 1973, what is the difference between the Female students (as % of total students) in Belgium and Female students (as % of total students) in Iceland?
Your answer should be compact. 0.15. In the year 1973, what is the difference between the Female students (as % of total students) of Belgium and Female students (as % of total students) of Sierra Leone?
Make the answer very short. 9.76. In the year 1973, what is the difference between the Female students (as % of total students) of Cameroon and Female students (as % of total students) of Iceland?
Keep it short and to the point. -5.28. In the year 1973, what is the difference between the Female students (as % of total students) in Cameroon and Female students (as % of total students) in Sierra Leone?
Your answer should be very brief. 4.33. In the year 1973, what is the difference between the Female students (as % of total students) of Iceland and Female students (as % of total students) of Sierra Leone?
Provide a succinct answer. 9.61. In the year 1974, what is the difference between the Female students (as % of total students) of Belgium and Female students (as % of total students) of Cameroon?
Your answer should be compact. 4.81. In the year 1974, what is the difference between the Female students (as % of total students) of Belgium and Female students (as % of total students) of Iceland?
Your response must be concise. -0.3. In the year 1974, what is the difference between the Female students (as % of total students) of Belgium and Female students (as % of total students) of Sierra Leone?
Ensure brevity in your answer.  9. In the year 1974, what is the difference between the Female students (as % of total students) of Cameroon and Female students (as % of total students) of Iceland?
Offer a very short reply. -5.11. In the year 1974, what is the difference between the Female students (as % of total students) in Cameroon and Female students (as % of total students) in Sierra Leone?
Provide a succinct answer. 4.19. In the year 1974, what is the difference between the Female students (as % of total students) in Iceland and Female students (as % of total students) in Sierra Leone?
Provide a succinct answer. 9.31. In the year 1975, what is the difference between the Female students (as % of total students) in Belgium and Female students (as % of total students) in Cameroon?
Your answer should be compact. 4.55. In the year 1975, what is the difference between the Female students (as % of total students) of Belgium and Female students (as % of total students) of Iceland?
Your response must be concise. -0.4. In the year 1975, what is the difference between the Female students (as % of total students) of Belgium and Female students (as % of total students) of Sierra Leone?
Keep it short and to the point. 9.4. In the year 1975, what is the difference between the Female students (as % of total students) of Cameroon and Female students (as % of total students) of Iceland?
Provide a succinct answer. -4.95. In the year 1975, what is the difference between the Female students (as % of total students) in Cameroon and Female students (as % of total students) in Sierra Leone?
Your answer should be very brief. 4.85. In the year 1975, what is the difference between the Female students (as % of total students) of Iceland and Female students (as % of total students) of Sierra Leone?
Give a very brief answer. 9.8. In the year 1976, what is the difference between the Female students (as % of total students) of Belgium and Female students (as % of total students) of Cameroon?
Your response must be concise. 4.16. In the year 1976, what is the difference between the Female students (as % of total students) of Belgium and Female students (as % of total students) of Iceland?
Make the answer very short. -0.18. In the year 1976, what is the difference between the Female students (as % of total students) of Belgium and Female students (as % of total students) of Sierra Leone?
Offer a terse response. 9.13. In the year 1976, what is the difference between the Female students (as % of total students) in Cameroon and Female students (as % of total students) in Iceland?
Your answer should be compact. -4.34. In the year 1976, what is the difference between the Female students (as % of total students) in Cameroon and Female students (as % of total students) in Sierra Leone?
Make the answer very short. 4.97. In the year 1976, what is the difference between the Female students (as % of total students) of Iceland and Female students (as % of total students) of Sierra Leone?
Offer a very short reply. 9.31. In the year 1977, what is the difference between the Female students (as % of total students) of Belgium and Female students (as % of total students) of Cameroon?
Your answer should be compact. 3.82. In the year 1977, what is the difference between the Female students (as % of total students) of Belgium and Female students (as % of total students) of Iceland?
Offer a very short reply. -0.43. In the year 1977, what is the difference between the Female students (as % of total students) in Belgium and Female students (as % of total students) in Sierra Leone?
Your answer should be very brief. 8.8. In the year 1977, what is the difference between the Female students (as % of total students) in Cameroon and Female students (as % of total students) in Iceland?
Your answer should be compact. -4.25. In the year 1977, what is the difference between the Female students (as % of total students) in Cameroon and Female students (as % of total students) in Sierra Leone?
Provide a succinct answer. 4.98. In the year 1977, what is the difference between the Female students (as % of total students) of Iceland and Female students (as % of total students) of Sierra Leone?
Make the answer very short. 9.22. In the year 1983, what is the difference between the Female students (as % of total students) in Belgium and Female students (as % of total students) in Cameroon?
Provide a short and direct response. 3.36. In the year 1983, what is the difference between the Female students (as % of total students) of Belgium and Female students (as % of total students) of Iceland?
Keep it short and to the point. 0.26. In the year 1983, what is the difference between the Female students (as % of total students) of Belgium and Female students (as % of total students) of Sierra Leone?
Provide a succinct answer. 7.95. In the year 1983, what is the difference between the Female students (as % of total students) of Cameroon and Female students (as % of total students) of Iceland?
Ensure brevity in your answer.  -3.1. In the year 1983, what is the difference between the Female students (as % of total students) in Cameroon and Female students (as % of total students) in Sierra Leone?
Ensure brevity in your answer.  4.58. In the year 1983, what is the difference between the Female students (as % of total students) in Iceland and Female students (as % of total students) in Sierra Leone?
Ensure brevity in your answer.  7.68. In the year 1984, what is the difference between the Female students (as % of total students) in Belgium and Female students (as % of total students) in Cameroon?
Keep it short and to the point. 3.4. In the year 1984, what is the difference between the Female students (as % of total students) in Belgium and Female students (as % of total students) in Iceland?
Give a very brief answer. 0.35. In the year 1984, what is the difference between the Female students (as % of total students) in Belgium and Female students (as % of total students) in Sierra Leone?
Ensure brevity in your answer.  7.97. In the year 1984, what is the difference between the Female students (as % of total students) in Cameroon and Female students (as % of total students) in Iceland?
Your answer should be compact. -3.05. In the year 1984, what is the difference between the Female students (as % of total students) of Cameroon and Female students (as % of total students) of Sierra Leone?
Ensure brevity in your answer.  4.58. In the year 1984, what is the difference between the Female students (as % of total students) of Iceland and Female students (as % of total students) of Sierra Leone?
Offer a terse response. 7.63. In the year 1988, what is the difference between the Female students (as % of total students) in Belgium and Female students (as % of total students) in Cameroon?
Offer a terse response. 3.22. In the year 1988, what is the difference between the Female students (as % of total students) of Belgium and Female students (as % of total students) of Iceland?
Keep it short and to the point. 0.13. In the year 1988, what is the difference between the Female students (as % of total students) in Belgium and Female students (as % of total students) in Sierra Leone?
Give a very brief answer. 8.1. In the year 1988, what is the difference between the Female students (as % of total students) in Cameroon and Female students (as % of total students) in Iceland?
Make the answer very short. -3.1. In the year 1988, what is the difference between the Female students (as % of total students) of Cameroon and Female students (as % of total students) of Sierra Leone?
Make the answer very short. 4.88. In the year 1988, what is the difference between the Female students (as % of total students) of Iceland and Female students (as % of total students) of Sierra Leone?
Ensure brevity in your answer.  7.98. What is the ratio of the Female students (as % of total students) of Sierra Leone in 1973 to that in 1974?
Provide a short and direct response. 0.99. What is the ratio of the Female students (as % of total students) of Belgium in 1973 to that in 1975?
Provide a short and direct response. 1.01. What is the ratio of the Female students (as % of total students) in Sierra Leone in 1973 to that in 1975?
Give a very brief answer. 1. What is the ratio of the Female students (as % of total students) of Belgium in 1973 to that in 1976?
Provide a short and direct response. 1.01. What is the ratio of the Female students (as % of total students) of Cameroon in 1973 to that in 1976?
Ensure brevity in your answer.  0.98. What is the ratio of the Female students (as % of total students) of Sierra Leone in 1973 to that in 1976?
Offer a terse response. 0.99. What is the ratio of the Female students (as % of total students) of Belgium in 1973 to that in 1977?
Offer a terse response. 1.01. What is the ratio of the Female students (as % of total students) of Cameroon in 1973 to that in 1977?
Keep it short and to the point. 0.97. What is the ratio of the Female students (as % of total students) in Sierra Leone in 1973 to that in 1977?
Offer a very short reply. 0.99. What is the ratio of the Female students (as % of total students) in Cameroon in 1973 to that in 1983?
Provide a short and direct response. 0.96. What is the ratio of the Female students (as % of total students) in Sierra Leone in 1973 to that in 1983?
Your response must be concise. 0.96. What is the ratio of the Female students (as % of total students) of Belgium in 1973 to that in 1984?
Keep it short and to the point. 1. What is the ratio of the Female students (as % of total students) of Iceland in 1973 to that in 1984?
Give a very brief answer. 1.01. What is the ratio of the Female students (as % of total students) in Cameroon in 1973 to that in 1988?
Offer a terse response. 0.95. What is the ratio of the Female students (as % of total students) in Iceland in 1973 to that in 1988?
Offer a very short reply. 1. What is the ratio of the Female students (as % of total students) of Sierra Leone in 1973 to that in 1988?
Keep it short and to the point. 0.96. What is the ratio of the Female students (as % of total students) in Iceland in 1974 to that in 1975?
Offer a very short reply. 1. What is the ratio of the Female students (as % of total students) of Sierra Leone in 1974 to that in 1975?
Give a very brief answer. 1.01. What is the ratio of the Female students (as % of total students) in Belgium in 1974 to that in 1976?
Provide a succinct answer. 1. What is the ratio of the Female students (as % of total students) in Cameroon in 1974 to that in 1976?
Give a very brief answer. 0.99. What is the ratio of the Female students (as % of total students) of Sierra Leone in 1974 to that in 1976?
Your response must be concise. 1. What is the ratio of the Female students (as % of total students) of Cameroon in 1974 to that in 1977?
Keep it short and to the point. 0.98. What is the ratio of the Female students (as % of total students) of Cameroon in 1974 to that in 1983?
Offer a terse response. 0.97. What is the ratio of the Female students (as % of total students) in Iceland in 1974 to that in 1983?
Provide a succinct answer. 1.01. What is the ratio of the Female students (as % of total students) of Sierra Leone in 1974 to that in 1983?
Ensure brevity in your answer.  0.97. What is the ratio of the Female students (as % of total students) of Belgium in 1974 to that in 1984?
Offer a very short reply. 1. What is the ratio of the Female students (as % of total students) in Cameroon in 1974 to that in 1984?
Offer a very short reply. 0.96. What is the ratio of the Female students (as % of total students) of Iceland in 1974 to that in 1984?
Provide a succinct answer. 1.01. What is the ratio of the Female students (as % of total students) of Sierra Leone in 1974 to that in 1984?
Provide a succinct answer. 0.97. What is the ratio of the Female students (as % of total students) of Belgium in 1974 to that in 1988?
Offer a terse response. 0.99. What is the ratio of the Female students (as % of total students) in Cameroon in 1974 to that in 1988?
Make the answer very short. 0.96. What is the ratio of the Female students (as % of total students) in Sierra Leone in 1974 to that in 1988?
Provide a succinct answer. 0.97. What is the ratio of the Female students (as % of total students) in Cameroon in 1975 to that in 1976?
Your answer should be compact. 0.99. What is the ratio of the Female students (as % of total students) in Iceland in 1975 to that in 1976?
Your response must be concise. 1. What is the ratio of the Female students (as % of total students) in Sierra Leone in 1975 to that in 1976?
Ensure brevity in your answer.  0.99. What is the ratio of the Female students (as % of total students) of Cameroon in 1975 to that in 1977?
Provide a succinct answer. 0.99. What is the ratio of the Female students (as % of total students) in Sierra Leone in 1975 to that in 1977?
Provide a short and direct response. 0.99. What is the ratio of the Female students (as % of total students) in Belgium in 1975 to that in 1983?
Offer a terse response. 1. What is the ratio of the Female students (as % of total students) in Cameroon in 1975 to that in 1983?
Give a very brief answer. 0.97. What is the ratio of the Female students (as % of total students) in Iceland in 1975 to that in 1983?
Keep it short and to the point. 1.01. What is the ratio of the Female students (as % of total students) of Sierra Leone in 1975 to that in 1983?
Your answer should be compact. 0.96. What is the ratio of the Female students (as % of total students) of Cameroon in 1975 to that in 1984?
Your answer should be very brief. 0.97. What is the ratio of the Female students (as % of total students) in Iceland in 1975 to that in 1984?
Your answer should be compact. 1.01. What is the ratio of the Female students (as % of total students) in Belgium in 1975 to that in 1988?
Keep it short and to the point. 0.99. What is the ratio of the Female students (as % of total students) in Cameroon in 1975 to that in 1988?
Offer a very short reply. 0.96. What is the ratio of the Female students (as % of total students) in Sierra Leone in 1975 to that in 1988?
Provide a succinct answer. 0.96. What is the ratio of the Female students (as % of total students) in Cameroon in 1976 to that in 1983?
Provide a succinct answer. 0.98. What is the ratio of the Female students (as % of total students) in Sierra Leone in 1976 to that in 1983?
Offer a terse response. 0.97. What is the ratio of the Female students (as % of total students) in Iceland in 1976 to that in 1984?
Offer a terse response. 1.01. What is the ratio of the Female students (as % of total students) in Cameroon in 1976 to that in 1988?
Your response must be concise. 0.97. What is the ratio of the Female students (as % of total students) of Sierra Leone in 1976 to that in 1988?
Your answer should be very brief. 0.97. What is the ratio of the Female students (as % of total students) in Belgium in 1977 to that in 1983?
Your answer should be compact. 0.99. What is the ratio of the Female students (as % of total students) of Iceland in 1977 to that in 1983?
Give a very brief answer. 1.01. What is the ratio of the Female students (as % of total students) of Sierra Leone in 1977 to that in 1983?
Your response must be concise. 0.97. What is the ratio of the Female students (as % of total students) of Belgium in 1977 to that in 1984?
Your answer should be very brief. 0.99. What is the ratio of the Female students (as % of total students) in Cameroon in 1977 to that in 1984?
Keep it short and to the point. 0.98. What is the ratio of the Female students (as % of total students) of Iceland in 1977 to that in 1984?
Provide a short and direct response. 1.01. What is the ratio of the Female students (as % of total students) of Sierra Leone in 1977 to that in 1984?
Your response must be concise. 0.97. What is the ratio of the Female students (as % of total students) in Cameroon in 1977 to that in 1988?
Your answer should be very brief. 0.98. What is the ratio of the Female students (as % of total students) in Iceland in 1977 to that in 1988?
Provide a succinct answer. 1. What is the ratio of the Female students (as % of total students) of Sierra Leone in 1977 to that in 1988?
Make the answer very short. 0.97. What is the ratio of the Female students (as % of total students) of Iceland in 1983 to that in 1984?
Give a very brief answer. 1. What is the ratio of the Female students (as % of total students) in Sierra Leone in 1983 to that in 1984?
Your answer should be compact. 1. What is the ratio of the Female students (as % of total students) of Sierra Leone in 1983 to that in 1988?
Make the answer very short. 1. What is the ratio of the Female students (as % of total students) of Iceland in 1984 to that in 1988?
Your response must be concise. 0.99. What is the difference between the highest and the second highest Female students (as % of total students) of Belgium?
Offer a very short reply. 0.02. What is the difference between the highest and the second highest Female students (as % of total students) in Cameroon?
Your answer should be compact. 0.27. What is the difference between the highest and the second highest Female students (as % of total students) in Iceland?
Provide a succinct answer. 0.03. What is the difference between the highest and the second highest Female students (as % of total students) of Sierra Leone?
Your answer should be very brief. 0.03. What is the difference between the highest and the lowest Female students (as % of total students) of Belgium?
Keep it short and to the point. 0.45. What is the difference between the highest and the lowest Female students (as % of total students) in Cameroon?
Provide a succinct answer. 2.23. What is the difference between the highest and the lowest Female students (as % of total students) of Iceland?
Offer a very short reply. 0.46. What is the difference between the highest and the lowest Female students (as % of total students) in Sierra Leone?
Give a very brief answer. 1.71. 